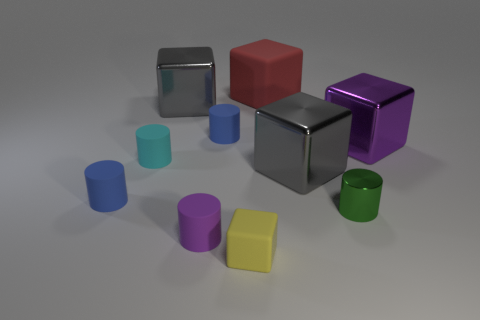Subtract all green cylinders. How many cylinders are left? 4 Subtract 2 cylinders. How many cylinders are left? 3 Add 4 big shiny blocks. How many big shiny blocks exist? 7 Subtract all gray cubes. How many cubes are left? 3 Subtract 0 green blocks. How many objects are left? 10 Subtract all cyan cylinders. Subtract all brown blocks. How many cylinders are left? 4 Subtract all blue balls. How many purple cylinders are left? 1 Subtract all tiny cyan matte objects. Subtract all large cubes. How many objects are left? 5 Add 4 yellow cubes. How many yellow cubes are left? 5 